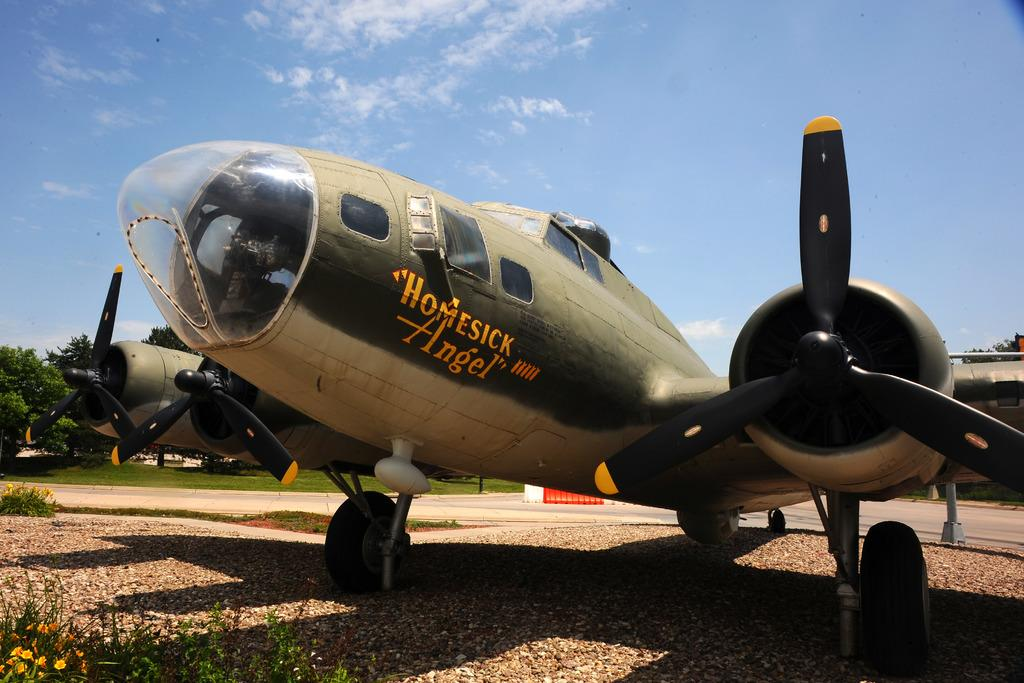Provide a one-sentence caption for the provided image. A World War II plane named Homesick Angel"sits parked in a museum. 